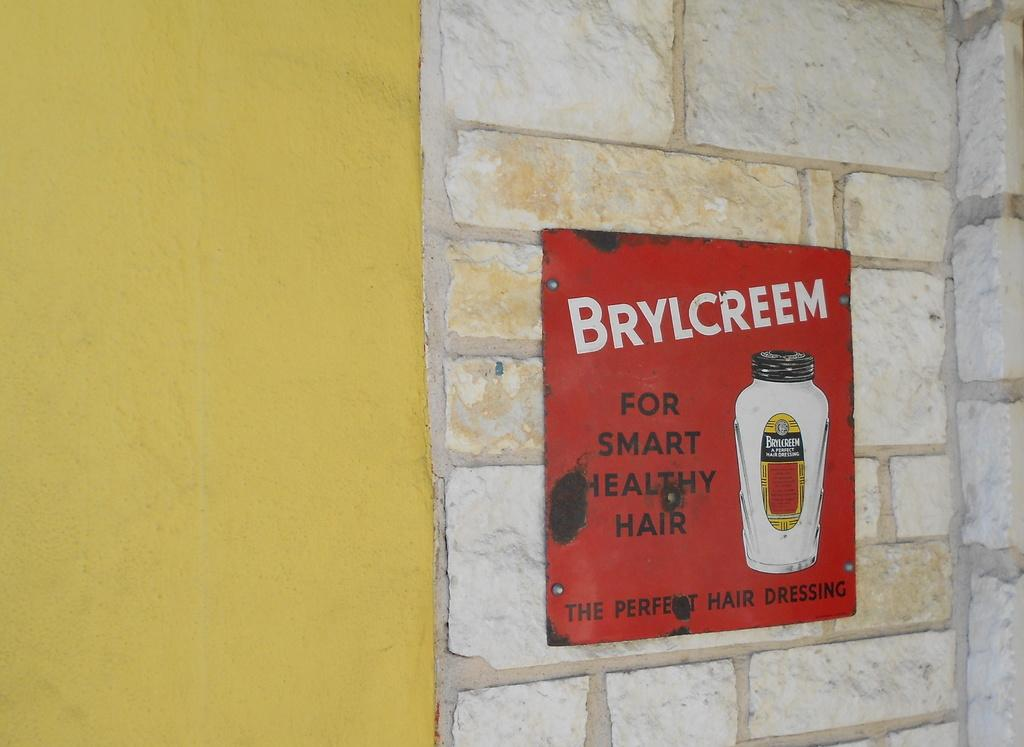Provide a one-sentence caption for the provided image. An ad for Brylcreem sits against a brick wall. 